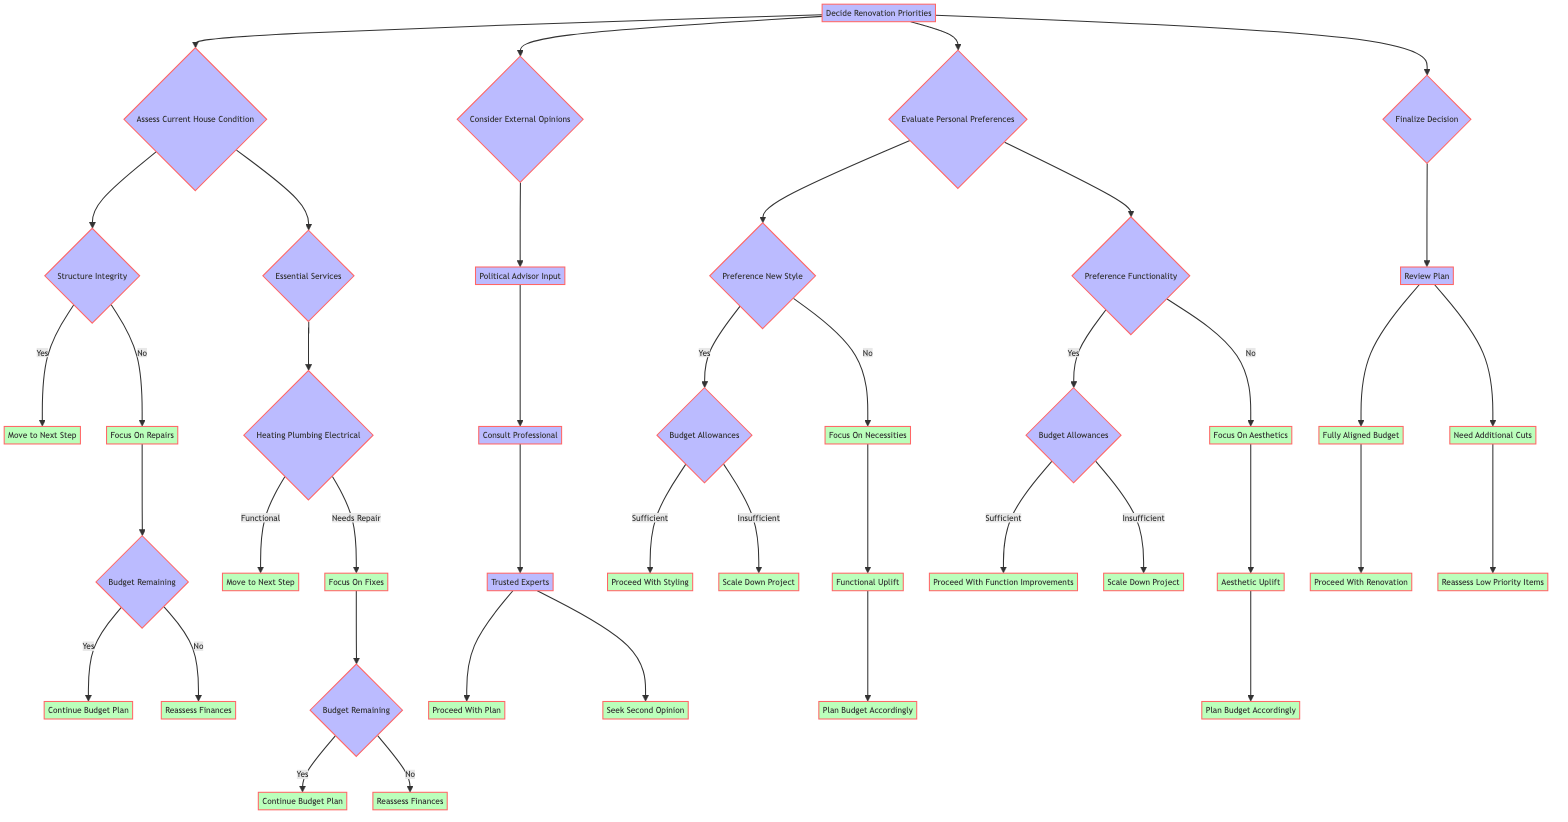What are the two main starting points in the decision tree? The decision tree begins with two main nodes, which are "Assess Current House Condition" and "Consider External Opinions." These nodes branch out into subsequent decisions and evaluations.
Answer: Assess Current House Condition, Consider External Opinions If "Structure Integrity" is "No," what is the next step? If "Structure Integrity" is "No," the flow indicates to "Focus On Repairs," leading the homeowner to prioritize necessary repairs before considering other renovations.
Answer: Focus On Repairs What happens if "Budget Remaining" is "No" after focusing on fixes? If "Budget Remaining" is "No" after focusing on fixes, the next step directs to "Reassess Finances," suggesting the need to review financial strategies and adjust plans accordingly.
Answer: Reassess Finances How many decisions are required to reach "Proceed With Renovation"? To get to "Proceed With Renovation," the flow requires several decisions: first, assessing the house condition, then ensuring budget alignment through reviews, leading to the final decision. The total distinct decision points are multiple, but the critical path consists of a minimum of three major evaluative steps.
Answer: Three What does "Consult Professional" indicate in the flow? "Consult Professional" is a pivotal decision point that signifies the need to seek expert guidance in both "Support New Projects" and "Prioritize Repairs," guiding the homeowner toward informed decision-making.
Answer: Seek Expert Guidance If the preference is for a "New Style" and the budget is "Insufficient," what is the outcome? If the preference is for a "New Style" and the "Budget Allowances" are deemed "Insufficient," the decision leads to "Scale Down Project," emphasizing the necessity to adjust renovation aspirations based on financial limitations.
Answer: Scale Down Project What is the action taken if "Need Additional Cuts" is identified during the review phase? If "Need Additional Cuts" is identified during the review of the renovation plan, the next step is to "Reassess Low Priority Items," focusing on reviewing and potentially eliminating less important renovations to stay within budget.
Answer: Reassess Low Priority Items What does the node "Plan Budget Accordingly" suggest? "Plan Budget Accordingly" suggests a reassessment or adjustment of the renovation project based on budgetary constraints identified in either "Focus On Necessities" or "Focus On Aesthetics," indicating strategies for prioritizing financial resources.
Answer: Adjust Budget Plan 